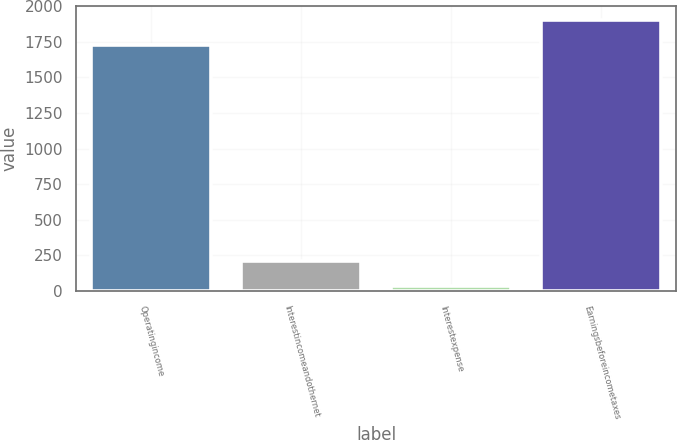Convert chart to OTSL. <chart><loc_0><loc_0><loc_500><loc_500><bar_chart><fcel>Operatingincome<fcel>Interestincomeandothernet<fcel>Interestexpense<fcel>Earningsbeforeincometaxes<nl><fcel>1728.5<fcel>211.08<fcel>33.3<fcel>1906.28<nl></chart> 